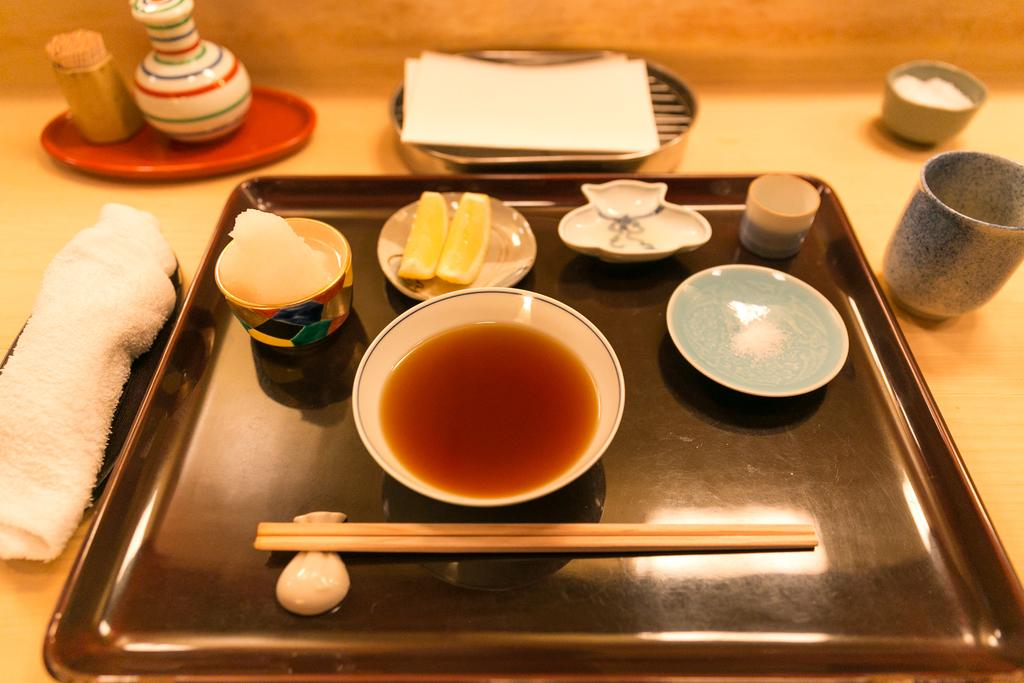What is in the main bowl in the image? There is a bowl of soup in the image. Are there any other bowls visible in the image? Yes, there are additional bowls in the image. What type of containers are present for drinking? There are glasses in the image. What utensils are visible in the image? Chopsticks are visible in the image. What items might be used for cleaning or wiping in the image? Napkins are present in the image for cleaning or wiping. What small, pointed objects are in the image? Toothpicks are in the image. Where are all these items located? All these items are on a table. What type of meal is being served in the image? The image does not provide enough information to determine the type of meal being served. 